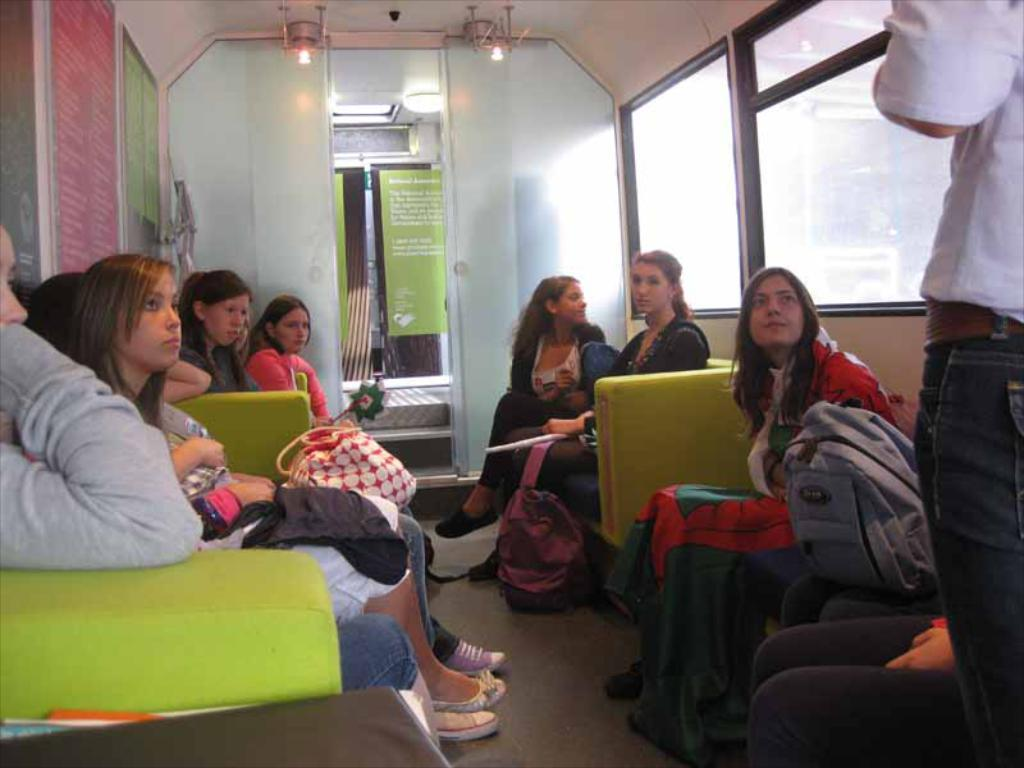What type of setting is depicted in the image? The image shows an interior view of a building. What are the people in the image doing? The people in the image are sitting on chairs. Can you identify any personal belongings in the image? Yes, there is a backpack visible in the image. What is on the walls in the image? There are boards on the walls in the image. How does the invention in the image help people sort their belongings? There is no invention present in the image; it shows people sitting on chairs, a backpack, and boards on the walls. What type of comb is used by the people in the image? There is no comb visible in the image. 